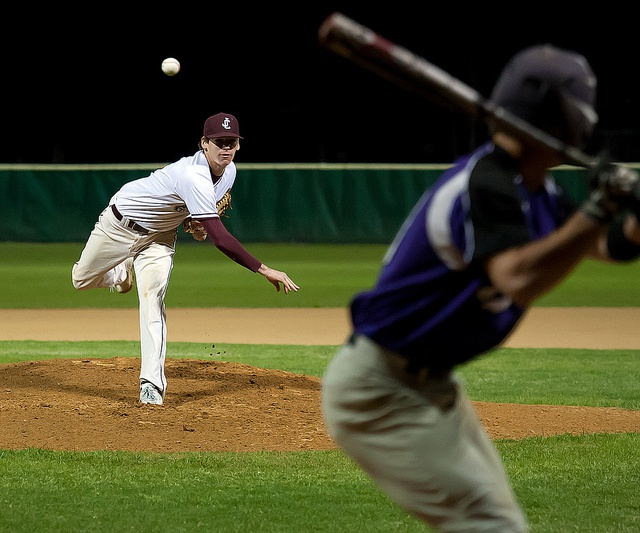Describe the objects in this image and their specific colors. I can see people in black, gray, darkgreen, and darkgray tones, people in black, white, maroon, and darkgray tones, baseball bat in black, gray, darkgray, and maroon tones, baseball glove in black, maroon, and tan tones, and sports ball in black, ivory, beige, darkgreen, and tan tones in this image. 